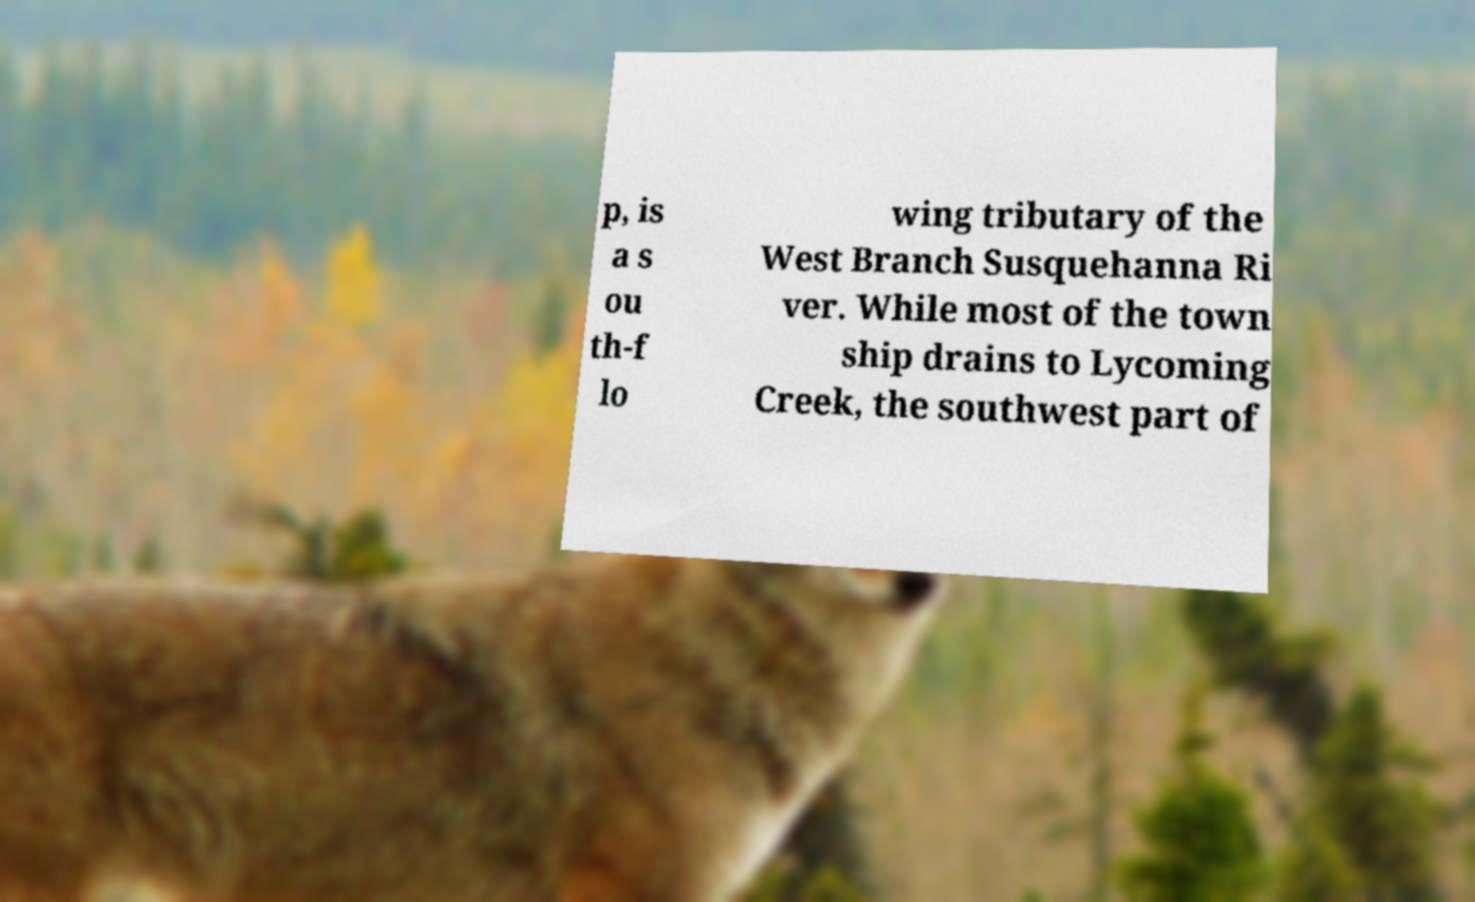Could you extract and type out the text from this image? p, is a s ou th-f lo wing tributary of the West Branch Susquehanna Ri ver. While most of the town ship drains to Lycoming Creek, the southwest part of 